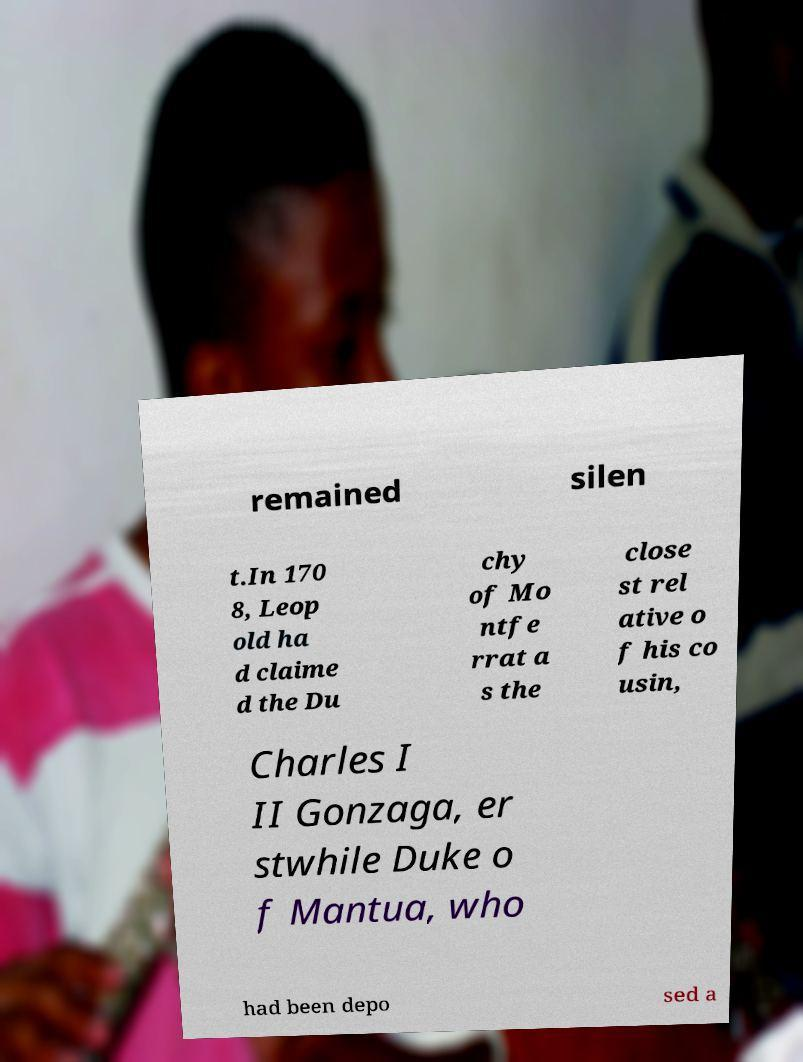I need the written content from this picture converted into text. Can you do that? remained silen t.In 170 8, Leop old ha d claime d the Du chy of Mo ntfe rrat a s the close st rel ative o f his co usin, Charles I II Gonzaga, er stwhile Duke o f Mantua, who had been depo sed a 